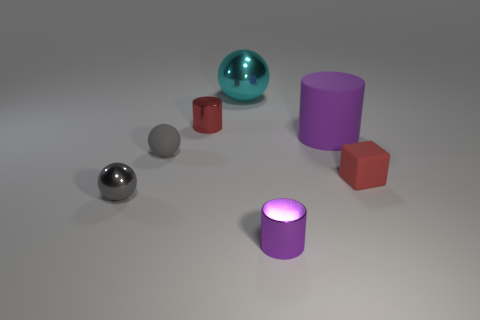What size is the metal object that is the same color as the matte ball?
Your response must be concise. Small. What color is the large ball?
Your response must be concise. Cyan. There is a large shiny object; does it have the same color as the metallic sphere that is to the left of the small red metal cylinder?
Keep it short and to the point. No. Is there anything else that is the same color as the large rubber thing?
Your answer should be compact. Yes. Is the material of the block the same as the big object that is in front of the small red shiny thing?
Give a very brief answer. Yes. Is the number of metal cylinders on the left side of the small gray metal thing less than the number of cyan things behind the tiny purple metallic object?
Offer a terse response. Yes. How many small red blocks are made of the same material as the large purple cylinder?
Provide a short and direct response. 1. There is a gray sphere on the left side of the small matte ball to the left of the big matte thing; are there any tiny metal objects that are right of it?
Offer a very short reply. Yes. What number of spheres are small purple metallic things or gray rubber objects?
Offer a terse response. 1. Does the tiny gray metallic thing have the same shape as the large object that is behind the small red metallic cylinder?
Make the answer very short. Yes. 